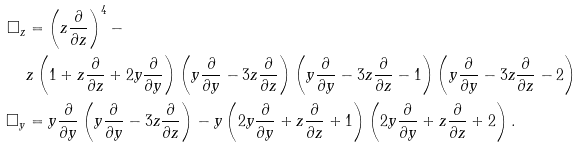<formula> <loc_0><loc_0><loc_500><loc_500>\Box _ { z } & = \left ( z \frac { \partial } { \partial z } \right ) ^ { 4 } - \\ & z \left ( 1 + z \frac { \partial } { \partial z } + 2 y \frac { \partial } { \partial y } \right ) \left ( y \frac { \partial } { \partial y } - 3 z \frac { \partial } { \partial z } \right ) \left ( y \frac { \partial } { \partial y } - 3 z \frac { \partial } { \partial z } - 1 \right ) \left ( y \frac { \partial } { \partial y } - 3 z \frac { \partial } { \partial z } - 2 \right ) \\ \Box _ { y } & = y \frac { \partial } { \partial y } \left ( y \frac { \partial } { \partial y } - 3 z \frac { \partial } { \partial z } \right ) - y \left ( 2 y \frac { \partial } { \partial y } + z \frac { \partial } { \partial z } + 1 \right ) \left ( 2 y \frac { \partial } { \partial y } + z \frac { \partial } { \partial z } + 2 \right ) .</formula> 